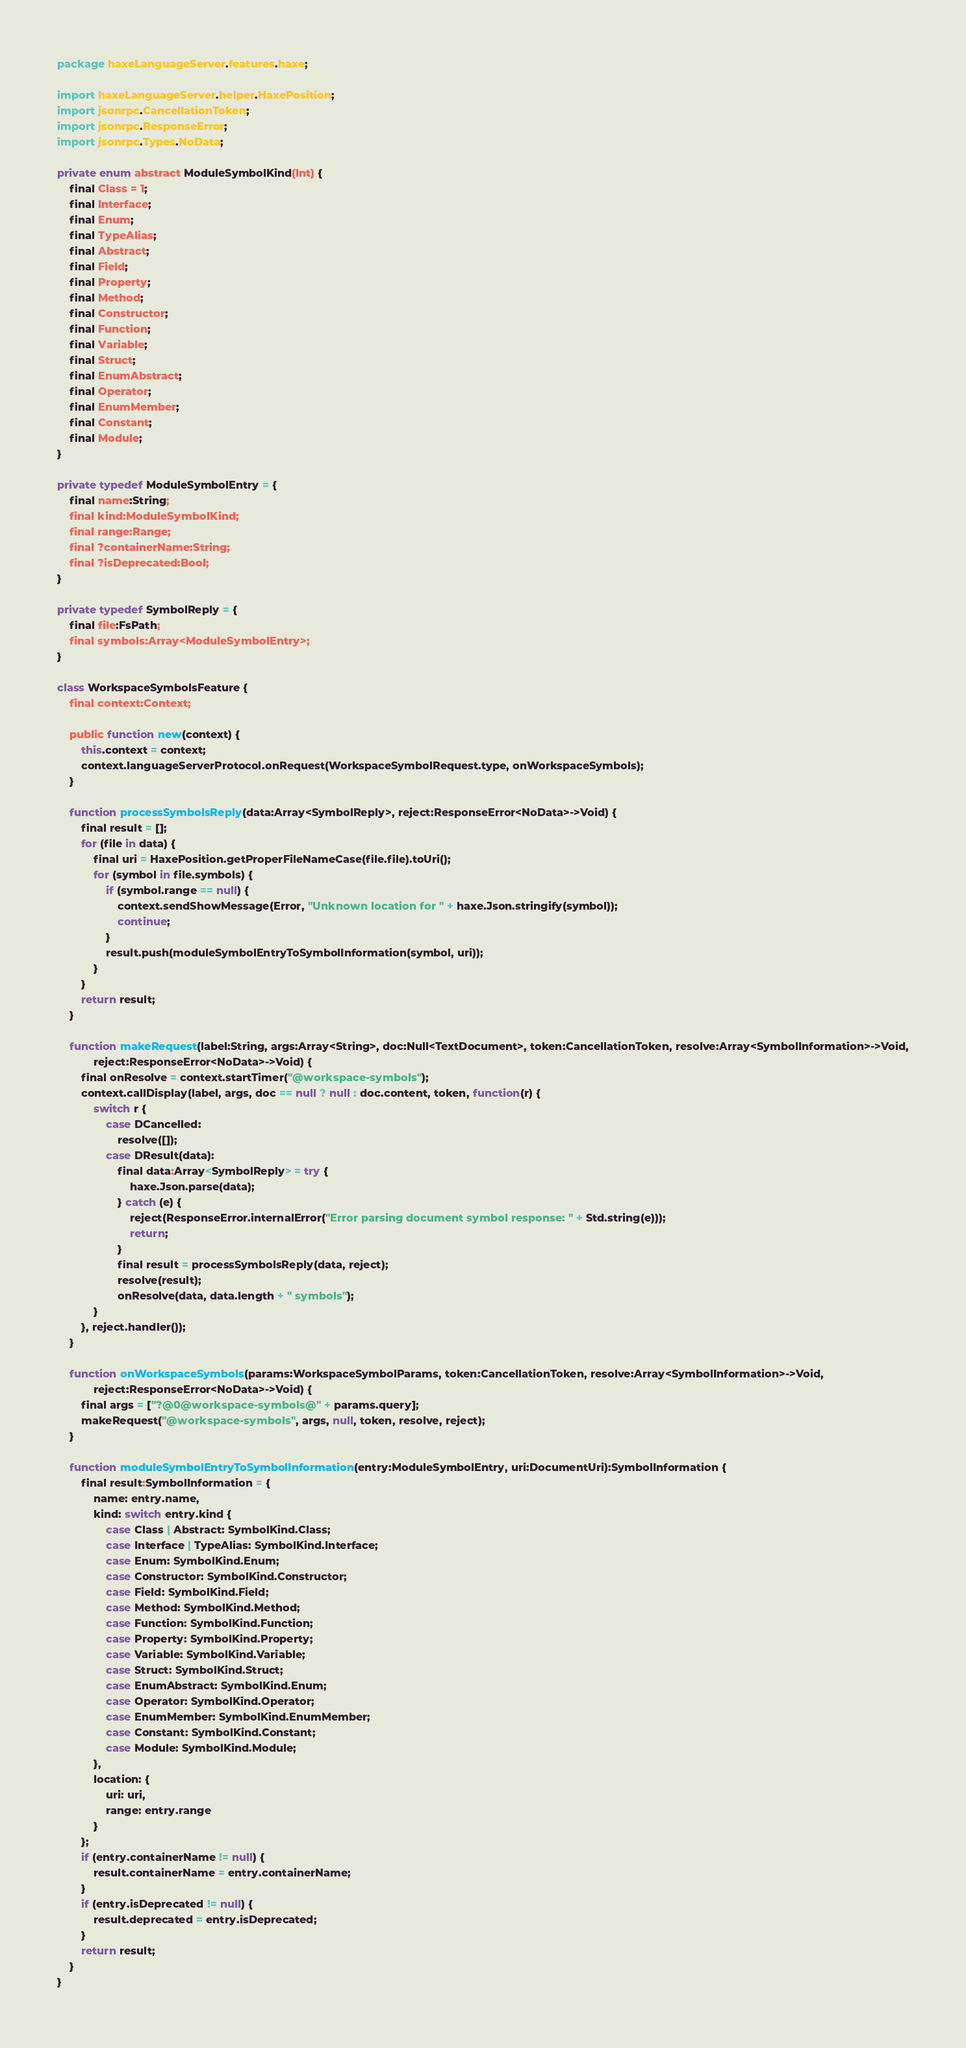<code> <loc_0><loc_0><loc_500><loc_500><_Haxe_>package haxeLanguageServer.features.haxe;

import haxeLanguageServer.helper.HaxePosition;
import jsonrpc.CancellationToken;
import jsonrpc.ResponseError;
import jsonrpc.Types.NoData;

private enum abstract ModuleSymbolKind(Int) {
	final Class = 1;
	final Interface;
	final Enum;
	final TypeAlias;
	final Abstract;
	final Field;
	final Property;
	final Method;
	final Constructor;
	final Function;
	final Variable;
	final Struct;
	final EnumAbstract;
	final Operator;
	final EnumMember;
	final Constant;
	final Module;
}

private typedef ModuleSymbolEntry = {
	final name:String;
	final kind:ModuleSymbolKind;
	final range:Range;
	final ?containerName:String;
	final ?isDeprecated:Bool;
}

private typedef SymbolReply = {
	final file:FsPath;
	final symbols:Array<ModuleSymbolEntry>;
}

class WorkspaceSymbolsFeature {
	final context:Context;

	public function new(context) {
		this.context = context;
		context.languageServerProtocol.onRequest(WorkspaceSymbolRequest.type, onWorkspaceSymbols);
	}

	function processSymbolsReply(data:Array<SymbolReply>, reject:ResponseError<NoData>->Void) {
		final result = [];
		for (file in data) {
			final uri = HaxePosition.getProperFileNameCase(file.file).toUri();
			for (symbol in file.symbols) {
				if (symbol.range == null) {
					context.sendShowMessage(Error, "Unknown location for " + haxe.Json.stringify(symbol));
					continue;
				}
				result.push(moduleSymbolEntryToSymbolInformation(symbol, uri));
			}
		}
		return result;
	}

	function makeRequest(label:String, args:Array<String>, doc:Null<TextDocument>, token:CancellationToken, resolve:Array<SymbolInformation>->Void,
			reject:ResponseError<NoData>->Void) {
		final onResolve = context.startTimer("@workspace-symbols");
		context.callDisplay(label, args, doc == null ? null : doc.content, token, function(r) {
			switch r {
				case DCancelled:
					resolve([]);
				case DResult(data):
					final data:Array<SymbolReply> = try {
						haxe.Json.parse(data);
					} catch (e) {
						reject(ResponseError.internalError("Error parsing document symbol response: " + Std.string(e)));
						return;
					}
					final result = processSymbolsReply(data, reject);
					resolve(result);
					onResolve(data, data.length + " symbols");
			}
		}, reject.handler());
	}

	function onWorkspaceSymbols(params:WorkspaceSymbolParams, token:CancellationToken, resolve:Array<SymbolInformation>->Void,
			reject:ResponseError<NoData>->Void) {
		final args = ["?@0@workspace-symbols@" + params.query];
		makeRequest("@workspace-symbols", args, null, token, resolve, reject);
	}

	function moduleSymbolEntryToSymbolInformation(entry:ModuleSymbolEntry, uri:DocumentUri):SymbolInformation {
		final result:SymbolInformation = {
			name: entry.name,
			kind: switch entry.kind {
				case Class | Abstract: SymbolKind.Class;
				case Interface | TypeAlias: SymbolKind.Interface;
				case Enum: SymbolKind.Enum;
				case Constructor: SymbolKind.Constructor;
				case Field: SymbolKind.Field;
				case Method: SymbolKind.Method;
				case Function: SymbolKind.Function;
				case Property: SymbolKind.Property;
				case Variable: SymbolKind.Variable;
				case Struct: SymbolKind.Struct;
				case EnumAbstract: SymbolKind.Enum;
				case Operator: SymbolKind.Operator;
				case EnumMember: SymbolKind.EnumMember;
				case Constant: SymbolKind.Constant;
				case Module: SymbolKind.Module;
			},
			location: {
				uri: uri,
				range: entry.range
			}
		};
		if (entry.containerName != null) {
			result.containerName = entry.containerName;
		}
		if (entry.isDeprecated != null) {
			result.deprecated = entry.isDeprecated;
		}
		return result;
	}
}
</code> 